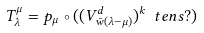Convert formula to latex. <formula><loc_0><loc_0><loc_500><loc_500>T _ { \lambda } ^ { \mu } = p _ { \mu } \circ ( ( V _ { \bar { w } ( \lambda - \mu ) } ^ { d } ) ^ { k } \ t e n s ? )</formula> 